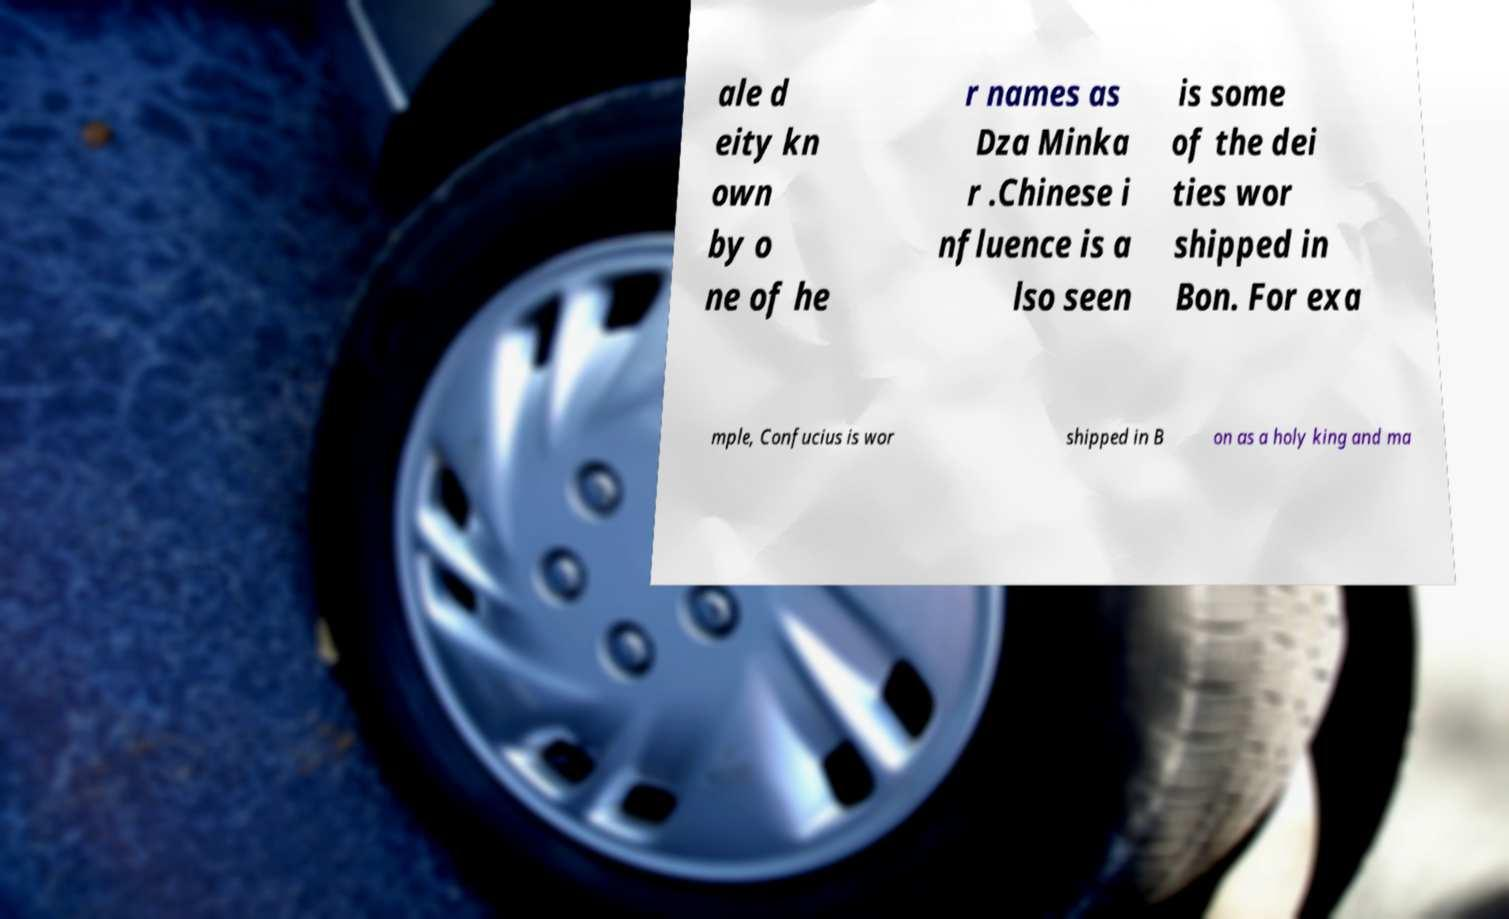Can you accurately transcribe the text from the provided image for me? ale d eity kn own by o ne of he r names as Dza Minka r .Chinese i nfluence is a lso seen is some of the dei ties wor shipped in Bon. For exa mple, Confucius is wor shipped in B on as a holy king and ma 